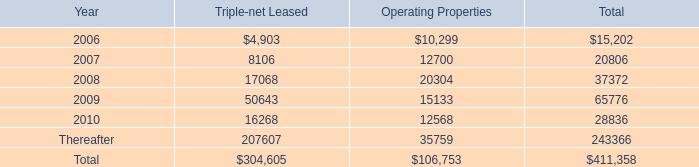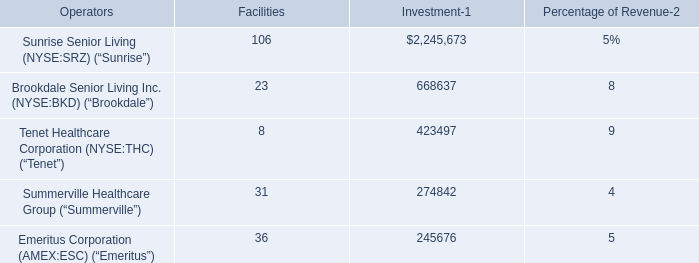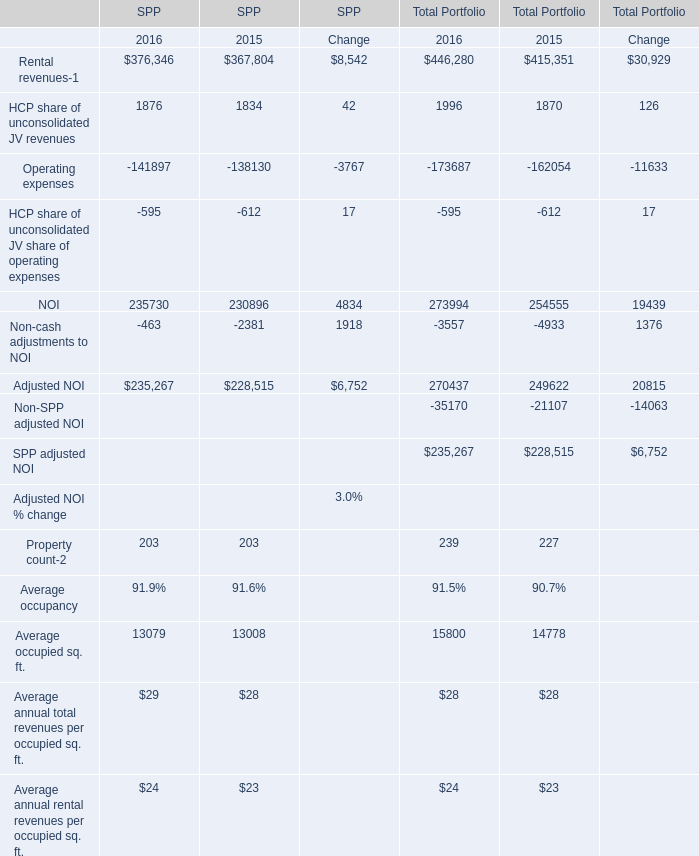What's the sum of all SPP that are positive in 2015 for SPP? 
Computations: ((((((367804 + 1834) + 230896) + 228515) + 203) + 28) + 23)
Answer: 829303.0. 